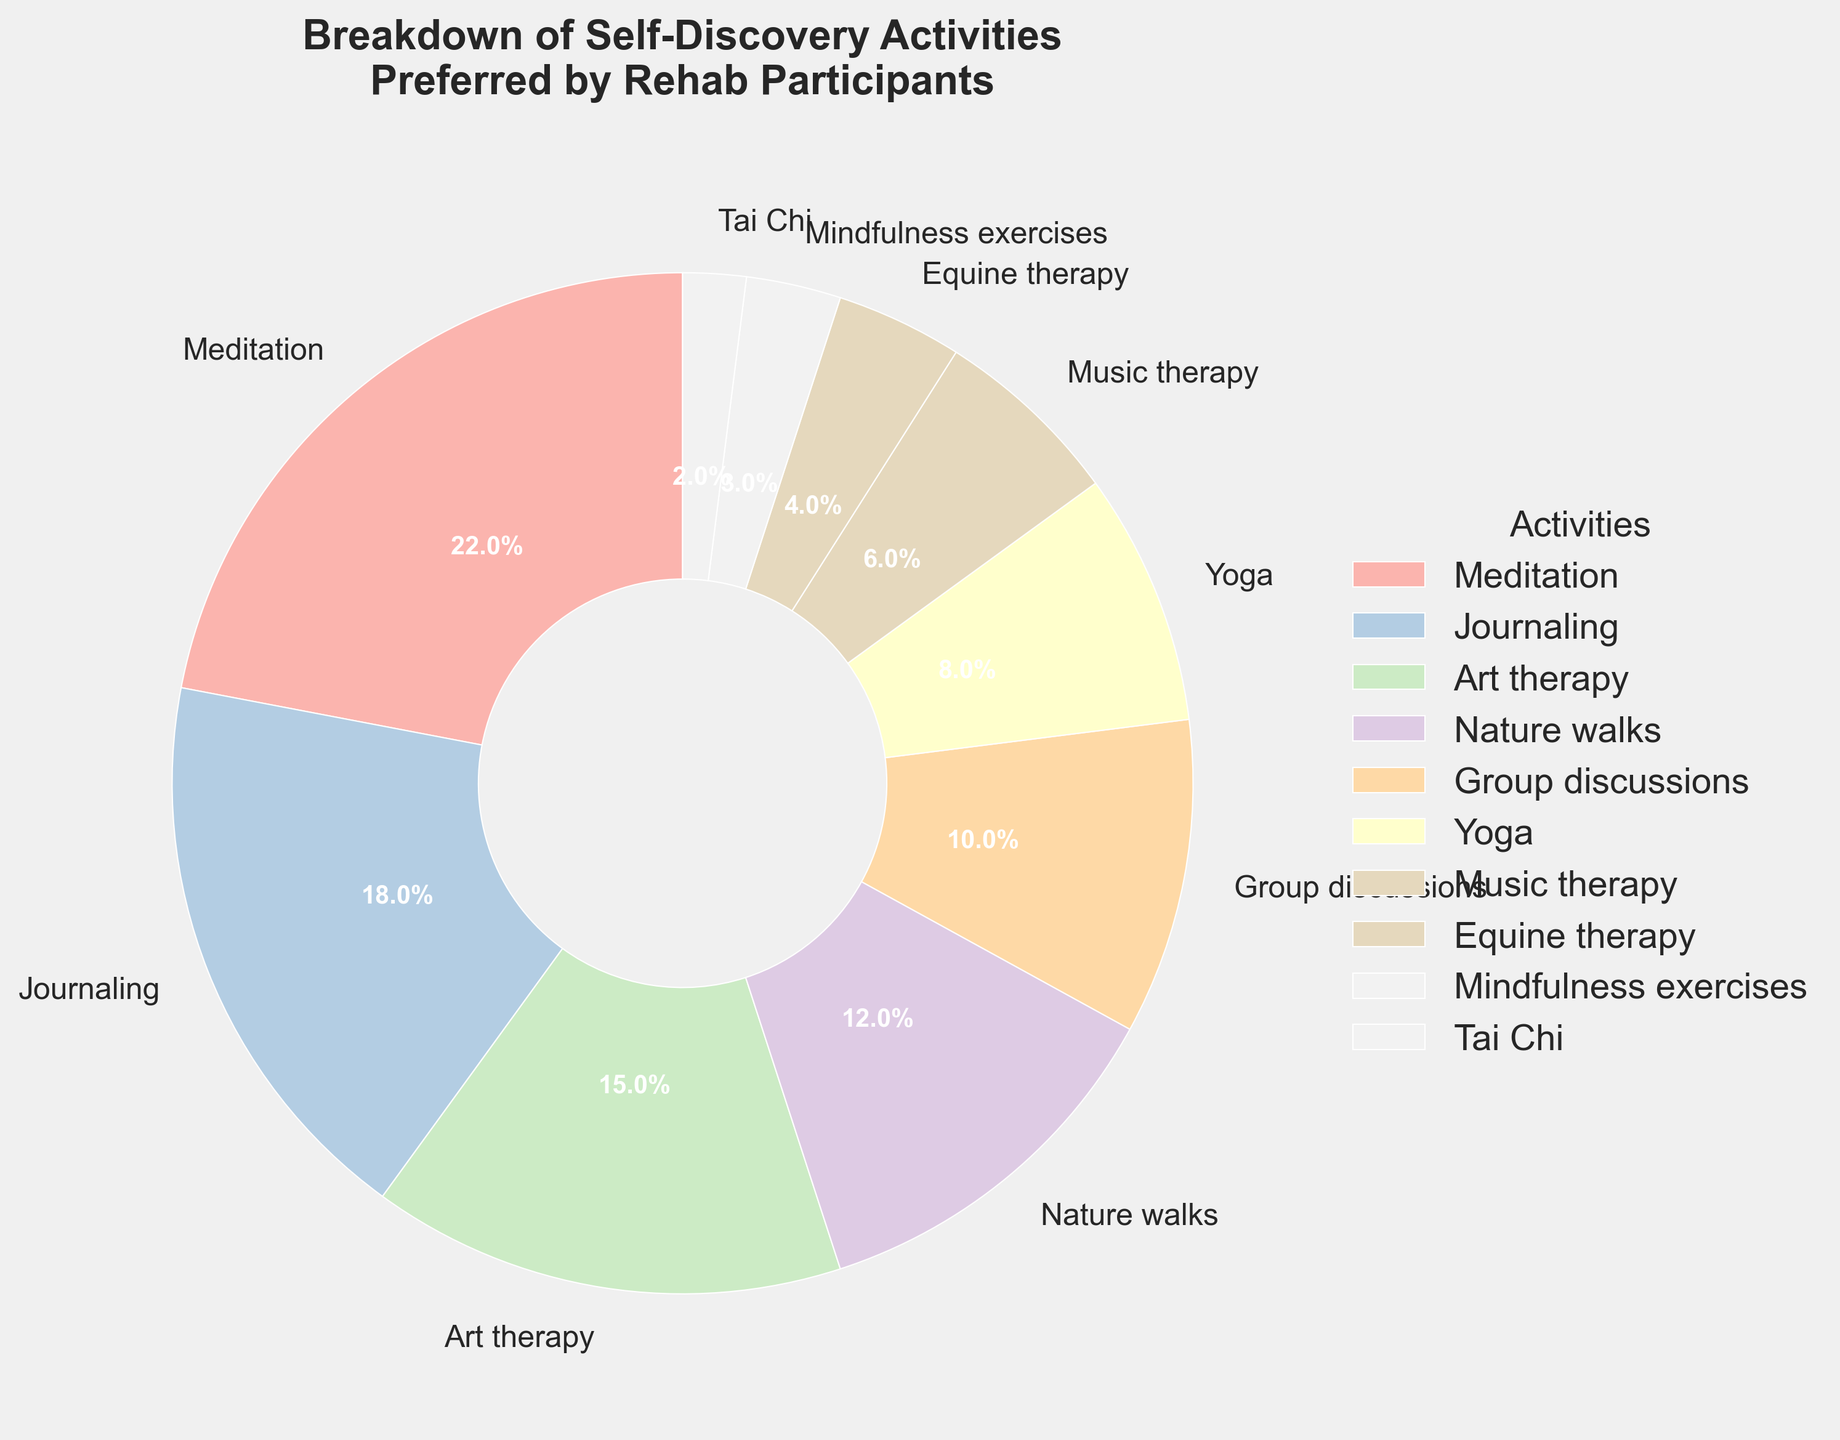Which activity is preferred by the highest percentage of rehab participants? According to the pie chart, Meditation has the largest wedge, indicating it is preferred by the highest percentage of participants.
Answer: Meditation What is the total percentage of participants preferring artistic activities (Art therapy, Music therapy, and Journaling)? Add the percentages of Art therapy (15%), Music therapy (6%), and Journaling (18%): 15 + 6 + 18 = 39%.
Answer: 39% Is the percentage of participants preferring Nature walks greater than those preferring Yoga? Compare the wedges for Nature walks (12%) and Yoga (8%); 12% is greater than 8%.
Answer: Yes What is the combined percentage of participants preferring group-based activities (Group discussions and Group yoga)? Add the percentages of Group discussions (10%) and Yoga (8%): 10 + 8 = 18%.
Answer: 18% Which activity is least preferred by the rehab participants? The activity with the smallest wedge is Tai Chi with 2%.
Answer: Tai Chi Is the percentage of participants engaging in Equine therapy more than double those engaging in Tai Chi? The percentage for Equine therapy is 4% and for Tai Chi is 2%. Double of 2% is 4%, so Equine therapy is not more than double Tai Chi.
Answer: No What percentage of participants prefer Meditation or Nature walks? Sum the percentages of Meditation (22%) and Nature walks (12%): 22 + 12 = 34%.
Answer: 34% How does the preference for Mindfulness exercises compare to that for Tai Chi? Mindfulness exercises (3%) have a slightly larger wedge than Tai Chi (2%). 3% is 1% more than 2%.
Answer: 1% more Which activity has a preference percentage closest to 10%? The wedge for Group discussions shows a preference of 10%, which is exactly 10%.
Answer: Group discussions 